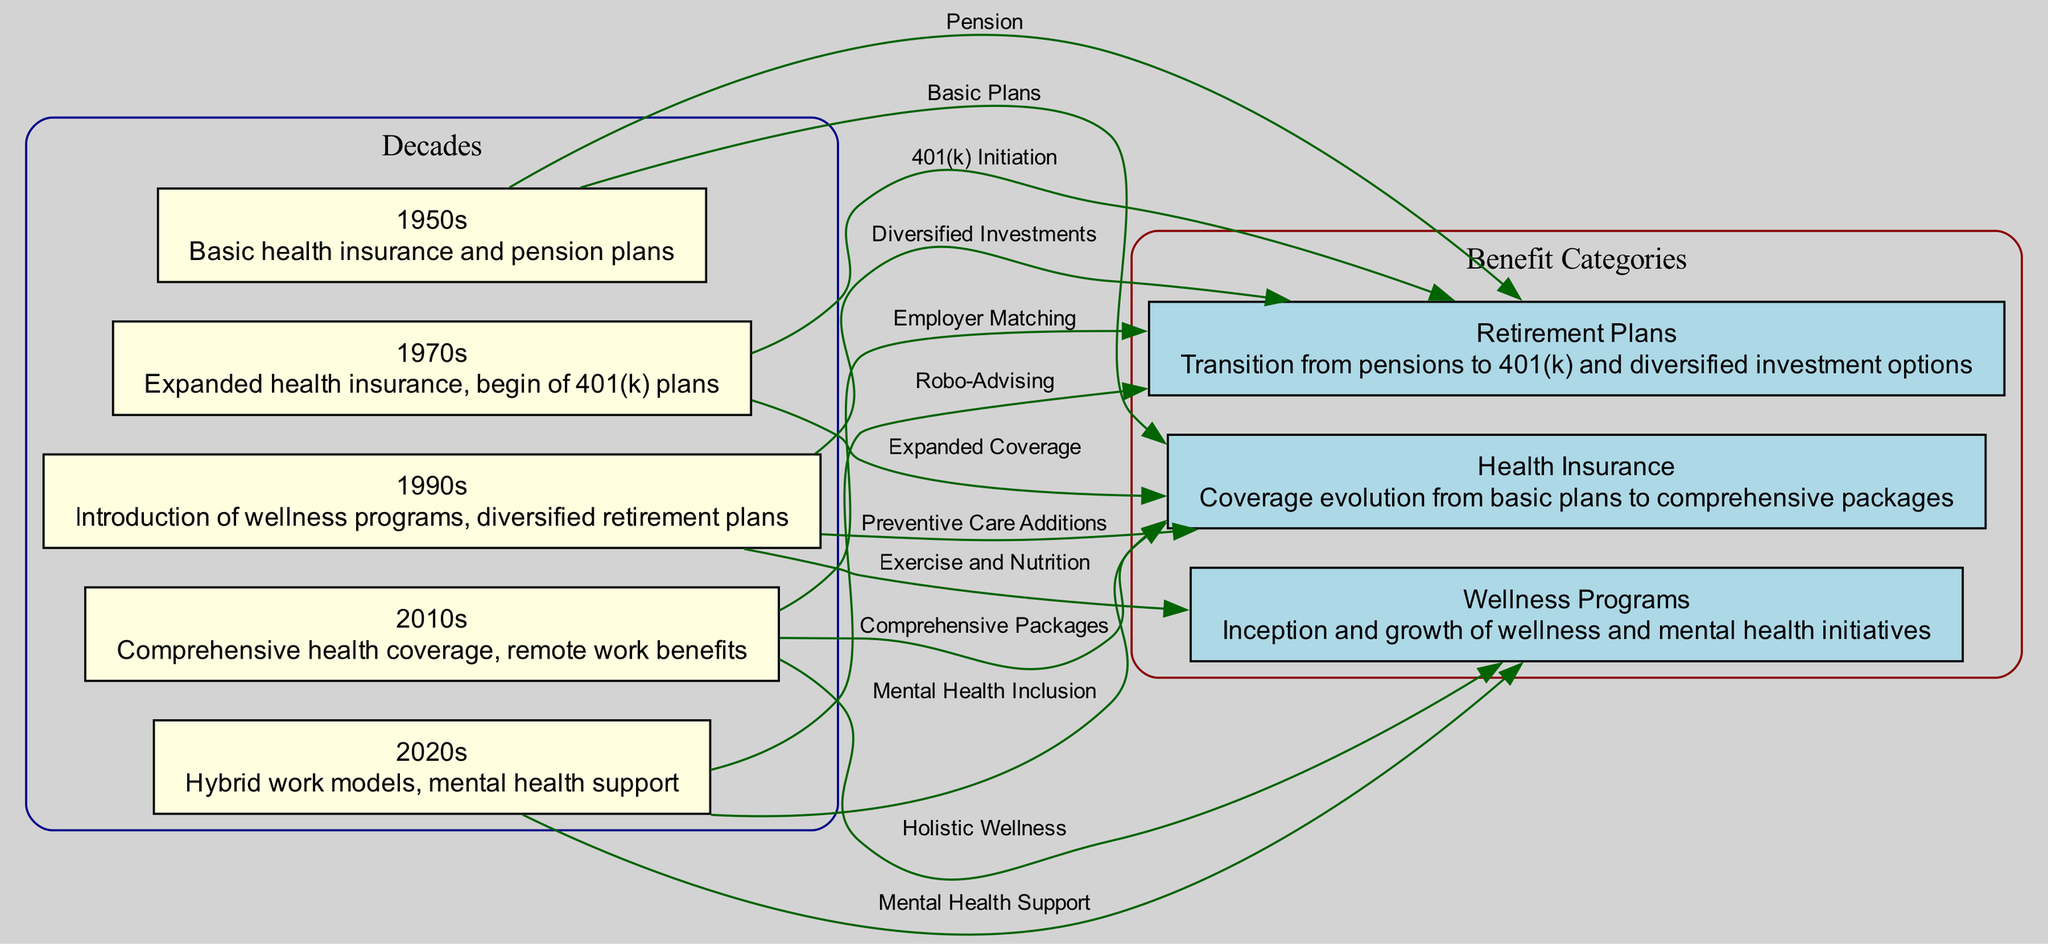What benefits were introduced in the 1990s? In the diagram, the 1990s node shows connections to both wellness programs and retirement plans, specifically highlighting the introduction of wellness programs and mentioning diverse investment options in retirement plans. Thus, these benefits were introduced in this decade.
Answer: Wellness programs What type of retirement plan was initiated in the 1970s? The diagram indicates that the 1970s node is connected to the retirement plans node with the label "401(k) Initiation." This describes the transition to a new type of retirement plan that started in that decade.
Answer: 401(k) How many nodes represent decades in the diagram? By counting the nodes listed that represent decades, we find five nodes labeled from the 1950s to the 2020s. Therefore, the total count represents the decades shown in the diagram.
Answer: 5 Which decade saw the inclusion of mental health support in employee benefits? Tracing the connections from the decade nodes, the 2020s node links to health insurance, indicating the evolution includes mental health inclusion at that time. Thus, mental health support was included in this decade.
Answer: 2020s What was a key feature of health insurance in the 2010s? Referring to the diagram, the 2010s node connects to health insurance with the label "Comprehensive Packages," which indicates that a key feature of health insurance during this decade was the comprehensive nature of the coverage.
Answer: Comprehensive Packages Which wellness program addition occurred in the 1990s? The 1990s node links to wellness programs with the label "Exercise and Nutrition," suggesting these were key additions to wellness programs during that decade, indicating a focus on health and well-being.
Answer: Exercise and Nutrition What type of support was highlighted in the 2020s for wellness programs? The diagram indicates that the 2020s node links to wellness programs labeled "Mental Health Support." This shows a focus on mental health as a significant aspect of wellness programs in the current decade.
Answer: Mental Health Support How did retirement plans evolve by the 2010s? The connection shows that the 2010s node links to retirement plans with the label "Employer Matching." This indicates that employer matching became an important feature of retirement plans by this decade.
Answer: Employer Matching 